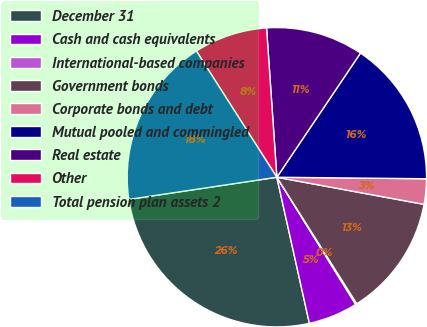Convert chart to OTSL. <chart><loc_0><loc_0><loc_500><loc_500><pie_chart><fcel>December 31<fcel>Cash and cash equivalents<fcel>International-based companies<fcel>Government bonds<fcel>Corporate bonds and debt<fcel>Mutual pooled and commingled<fcel>Real estate<fcel>Other<fcel>Total pension plan assets 2<nl><fcel>26.12%<fcel>5.34%<fcel>0.14%<fcel>13.13%<fcel>2.74%<fcel>15.73%<fcel>10.53%<fcel>7.94%<fcel>18.33%<nl></chart> 